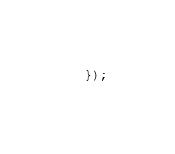Convert code to text. <code><loc_0><loc_0><loc_500><loc_500><_JavaScript_>  });
</code> 